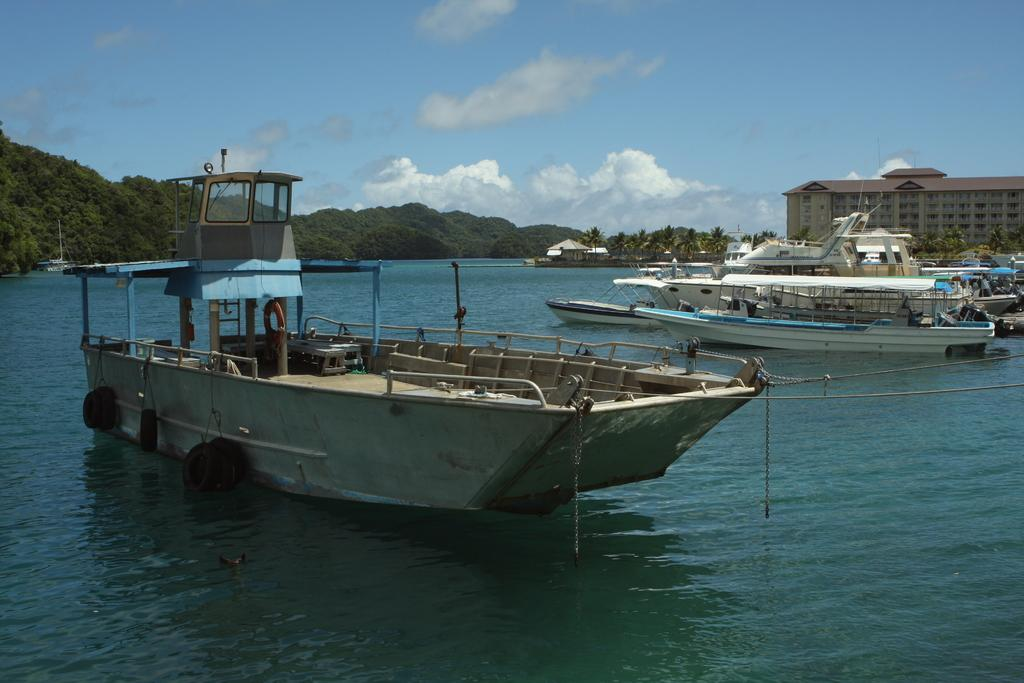What can be seen in the water in the image? There are fleets of boats in the water. What is visible in the background of the image? There are trees, mountains, buildings, a fence, a house, and the sky visible in the background of the image. What time of day might the image have been taken? The image is likely taken during the day, as the sky is visible and there is no indication of darkness. What type of metal is used to construct the thrill ride in the image? There is no thrill ride present in the image; it features fleets of boats in the water and various background elements. 